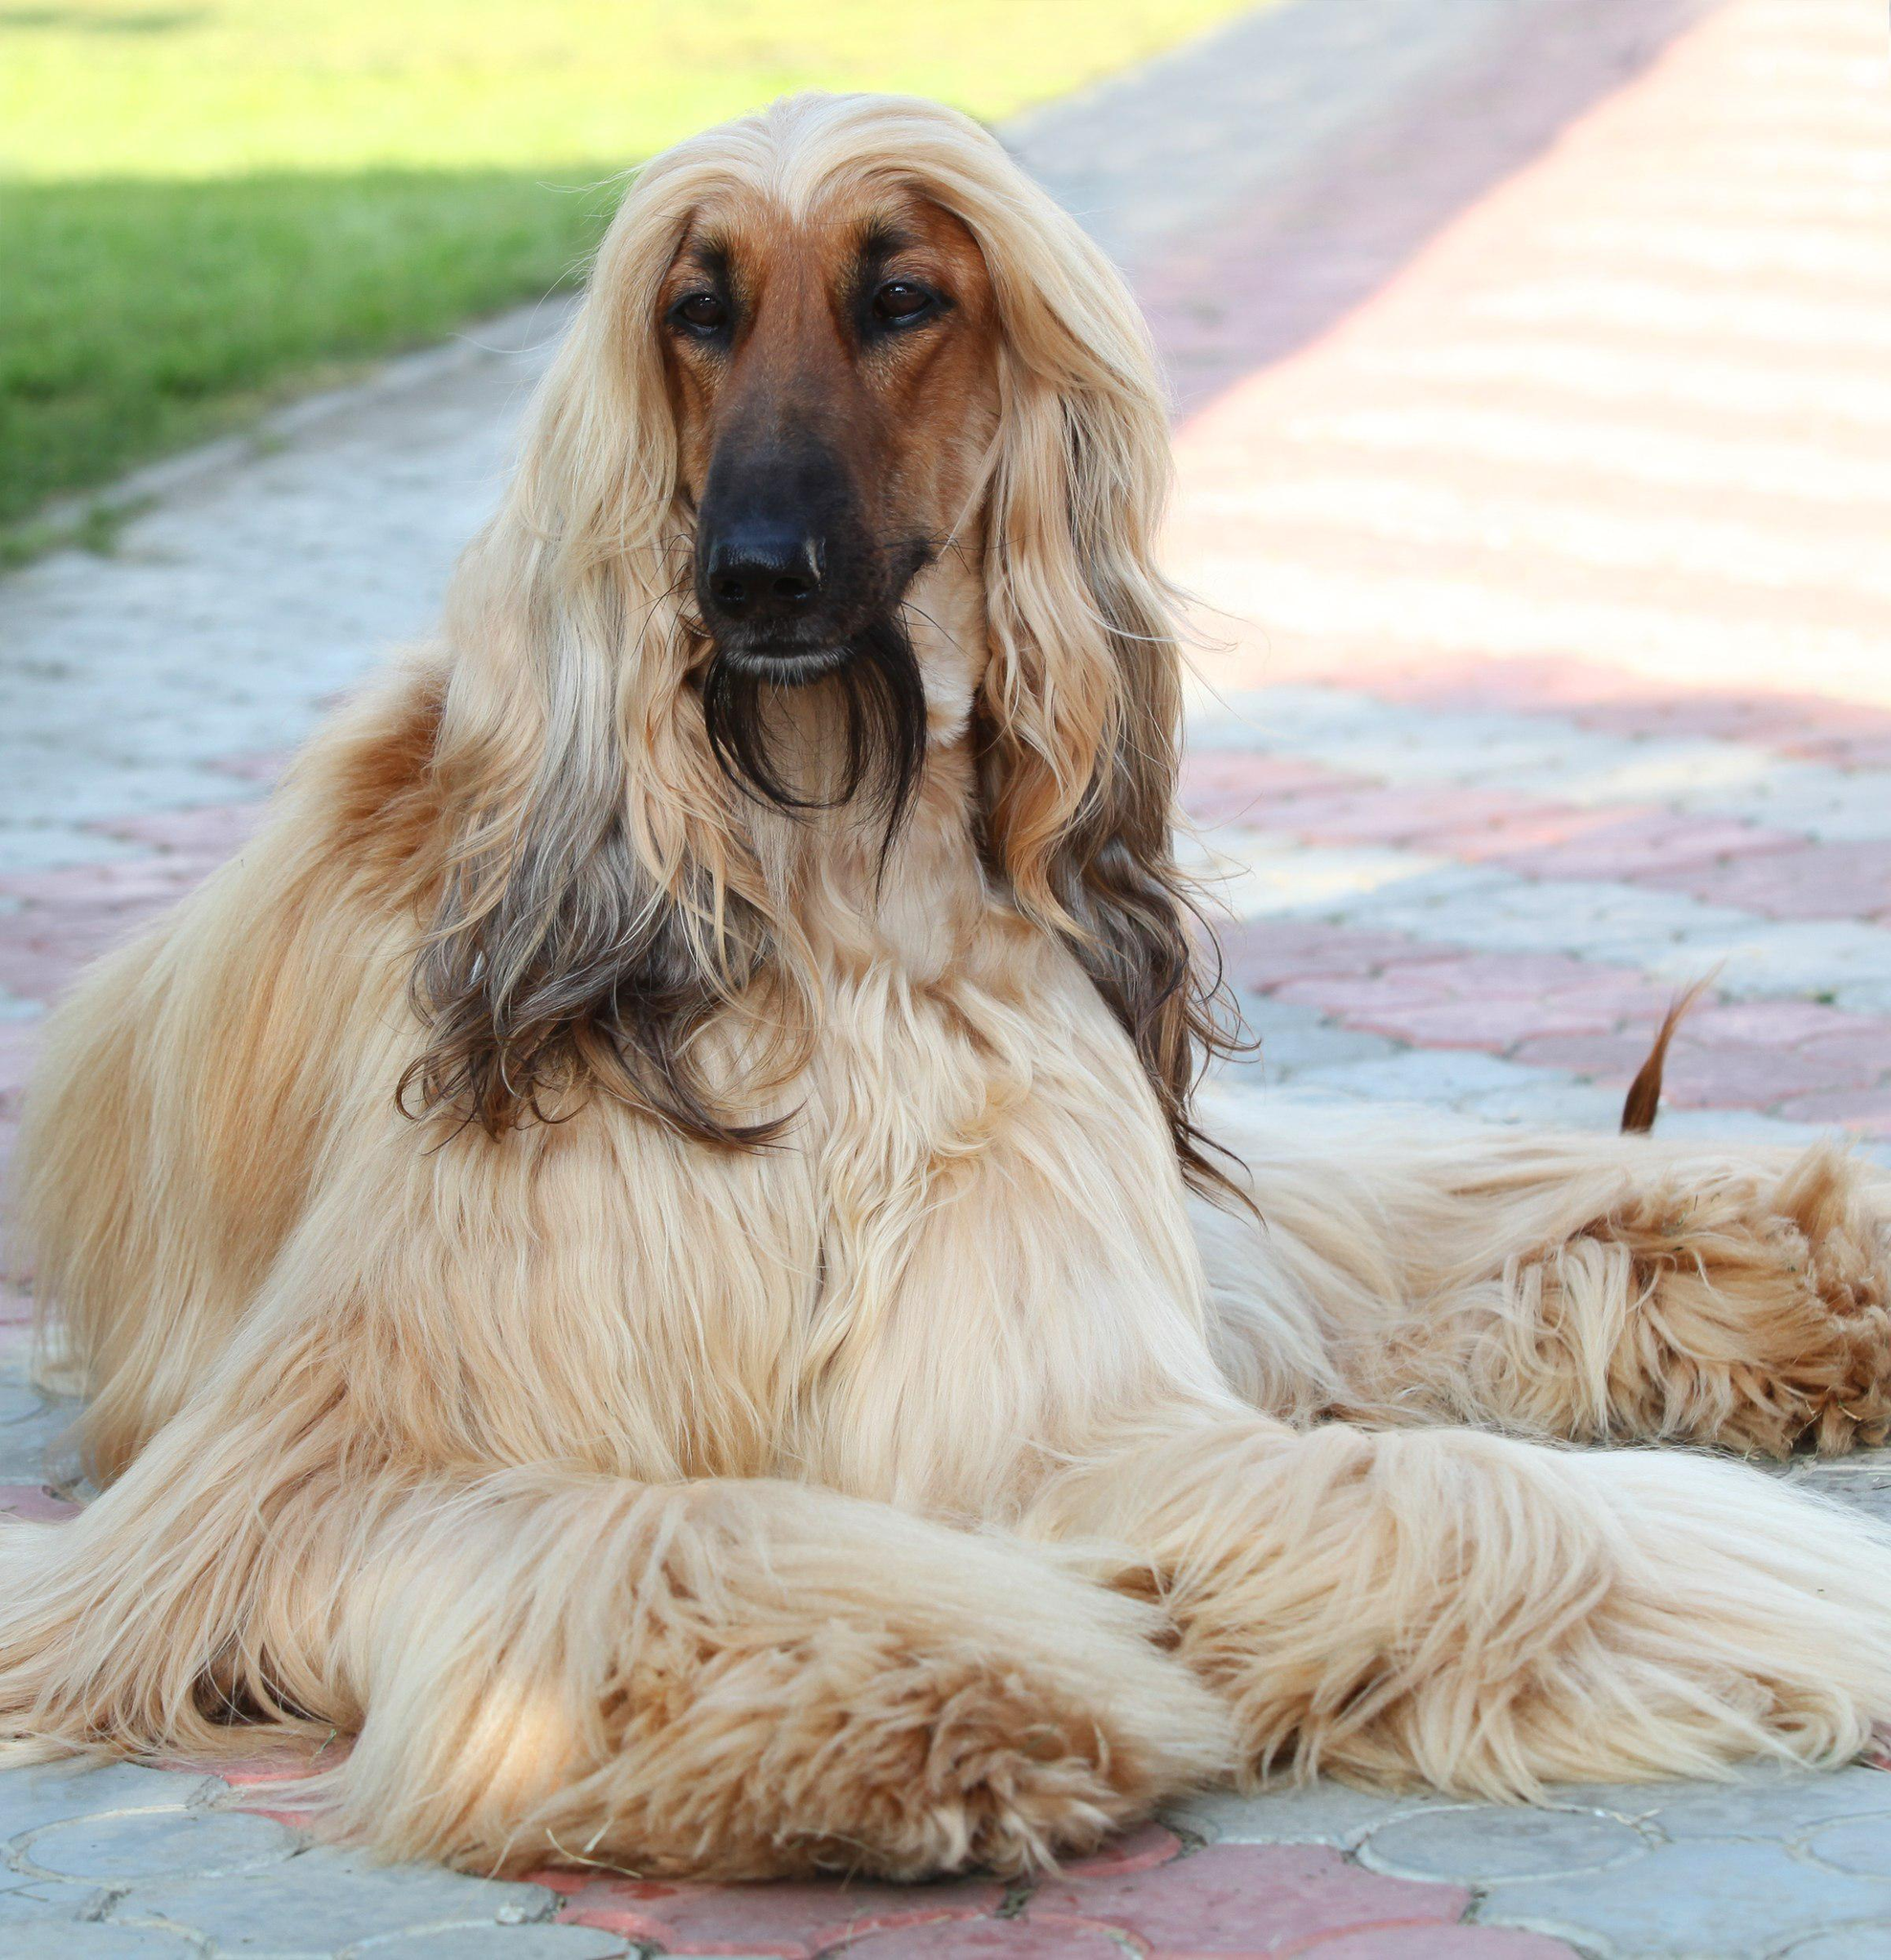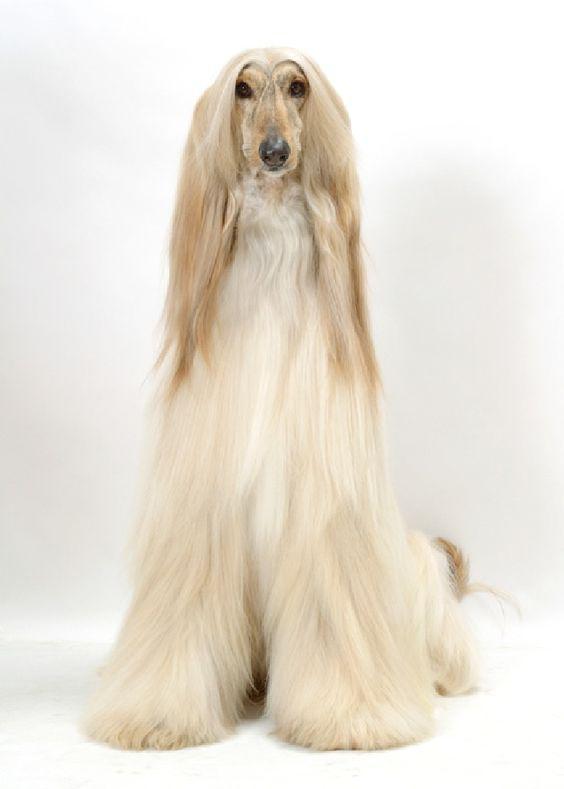The first image is the image on the left, the second image is the image on the right. Considering the images on both sides, is "The legs of the Afphan dog are not visible in at least one of the images." valid? Answer yes or no. No. The first image is the image on the left, the second image is the image on the right. For the images displayed, is the sentence "An image shows a reclining hound with its front paws extended in front of its body." factually correct? Answer yes or no. Yes. 